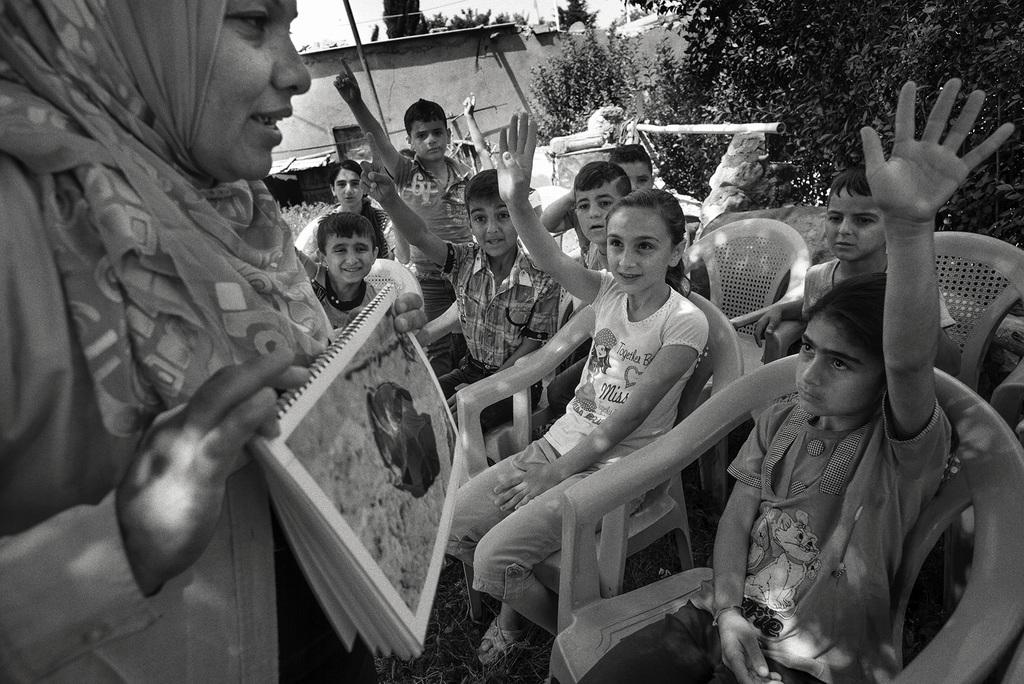What is the color scheme of the image? The image is black and white. What type of furniture can be seen in the image? There are chairs in the image. Who is sitting on the chairs? Children are sitting on the chairs. What is the person on the left side of the image doing? The person is holding a book. What can be seen at the top of the image? Trees are visible at the top of the image. What invention is the person on the left side of the image demonstrating? There is no invention being demonstrated in the image; the person is simply holding a book. What is the manager's role in the scene depicted in the image? There is no manager present in the image, so it is not possible to determine their role. 